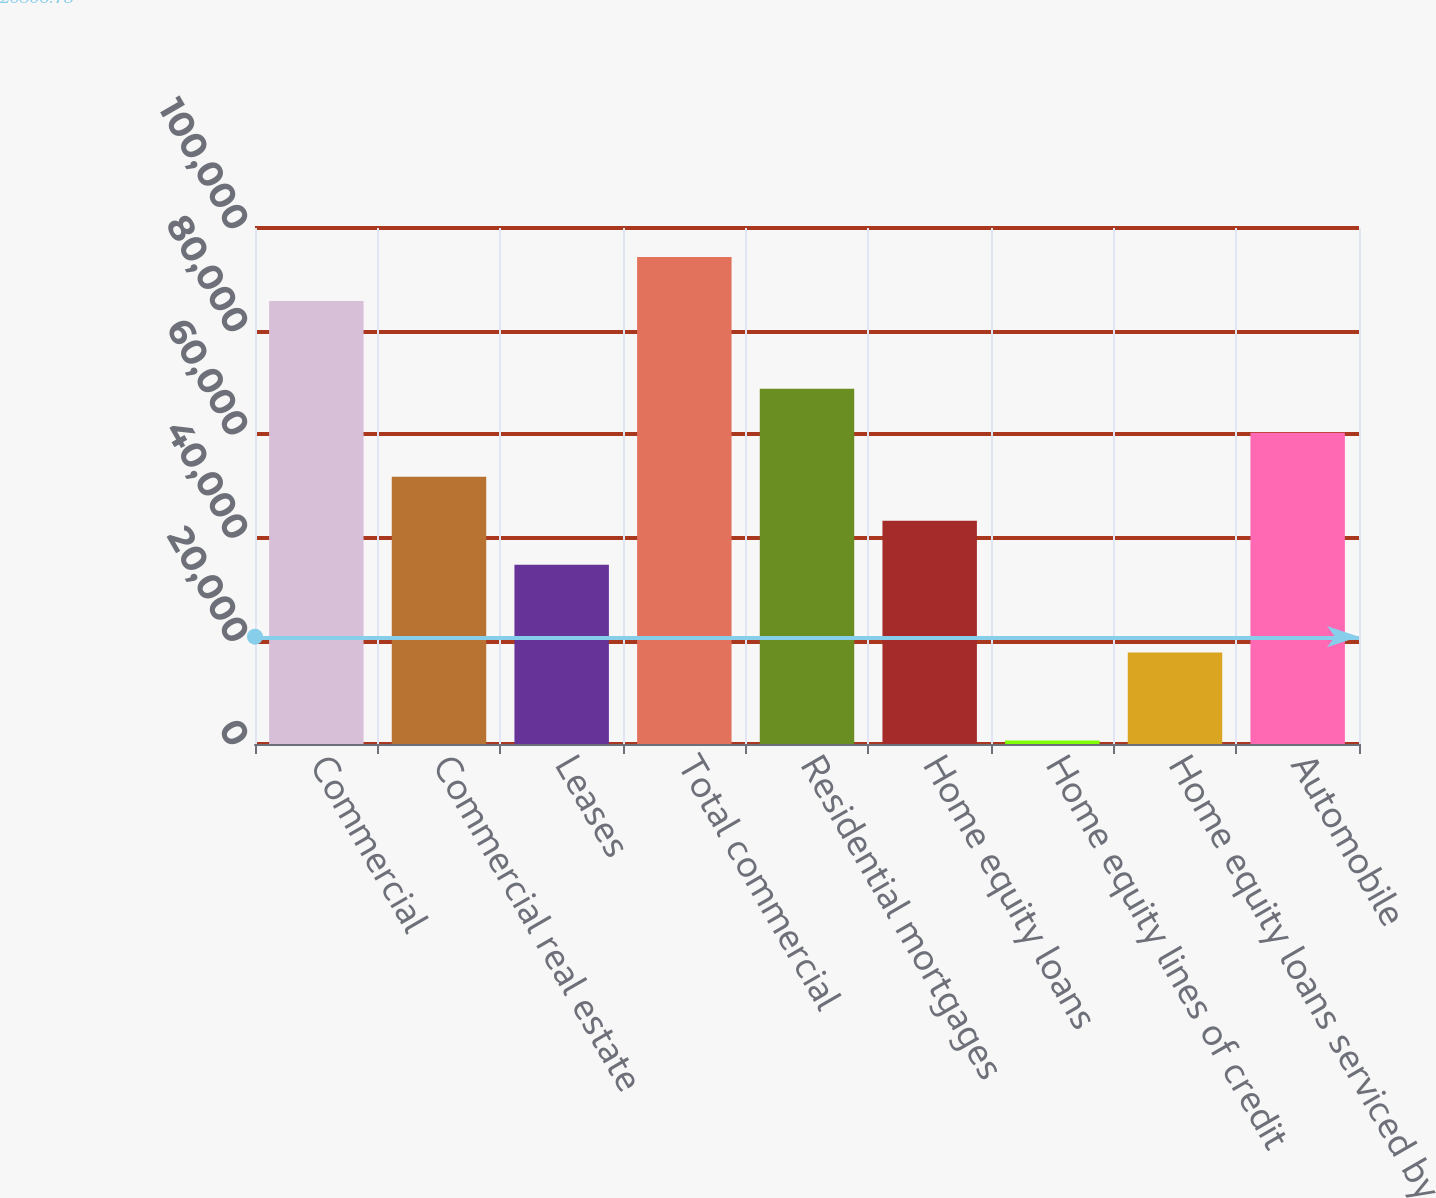Convert chart. <chart><loc_0><loc_0><loc_500><loc_500><bar_chart><fcel>Commercial<fcel>Commercial real estate<fcel>Leases<fcel>Total commercial<fcel>Residential mortgages<fcel>Home equity loans<fcel>Home equity lines of credit<fcel>Home equity loans serviced by<fcel>Automobile<nl><fcel>85859<fcel>51787<fcel>34751<fcel>94377<fcel>68823<fcel>43269<fcel>679<fcel>17715<fcel>60305<nl></chart> 